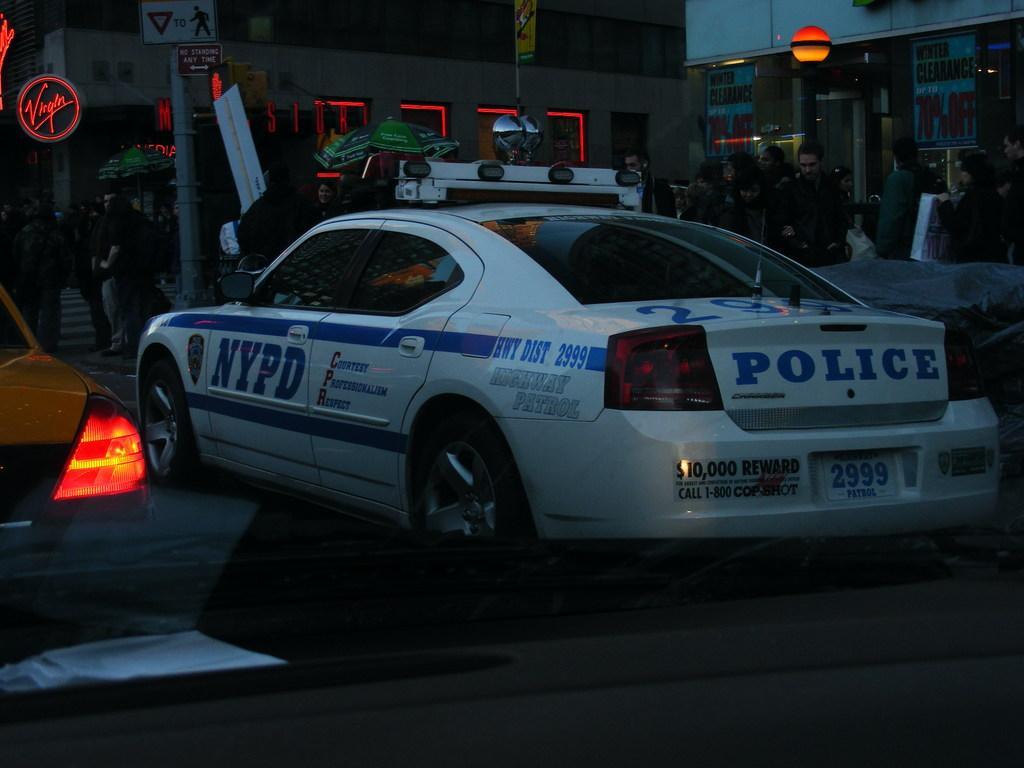Describe this image in one or two sentences. In this image I can see the dark picture in which I can see few vehicles on the ground. I can see few persons standing, few buildings, few lights, few boards and a pole. 